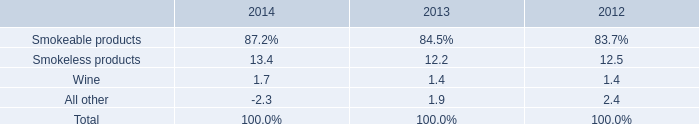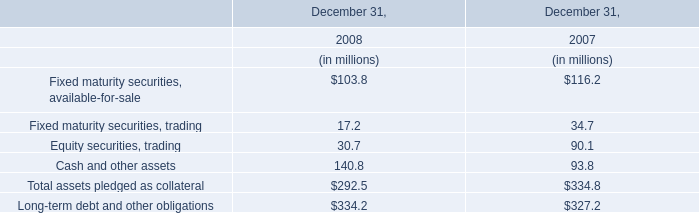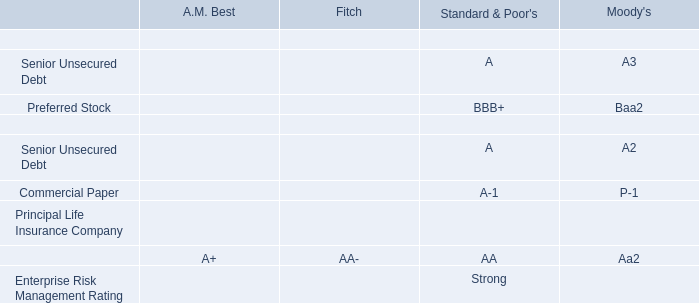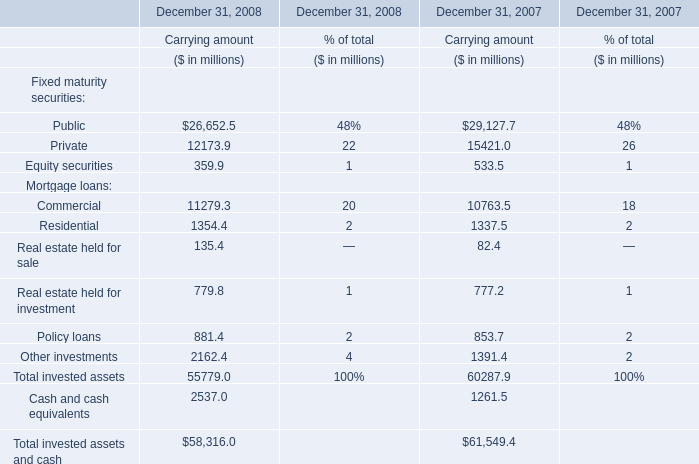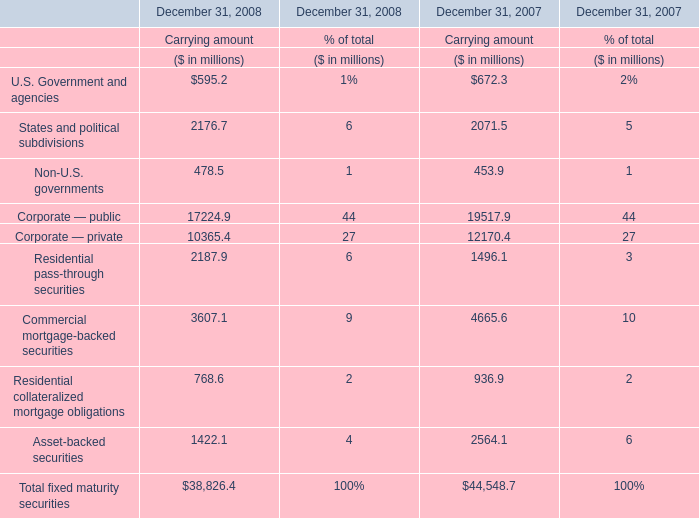In the year with largest amount of Residential pass-through securities for Carrying amount, what's the increasing rate of Corporate — public for Carrying amount? 
Computations: ((17224.9 - 19517.9) / 19517.9)
Answer: -0.11748. 